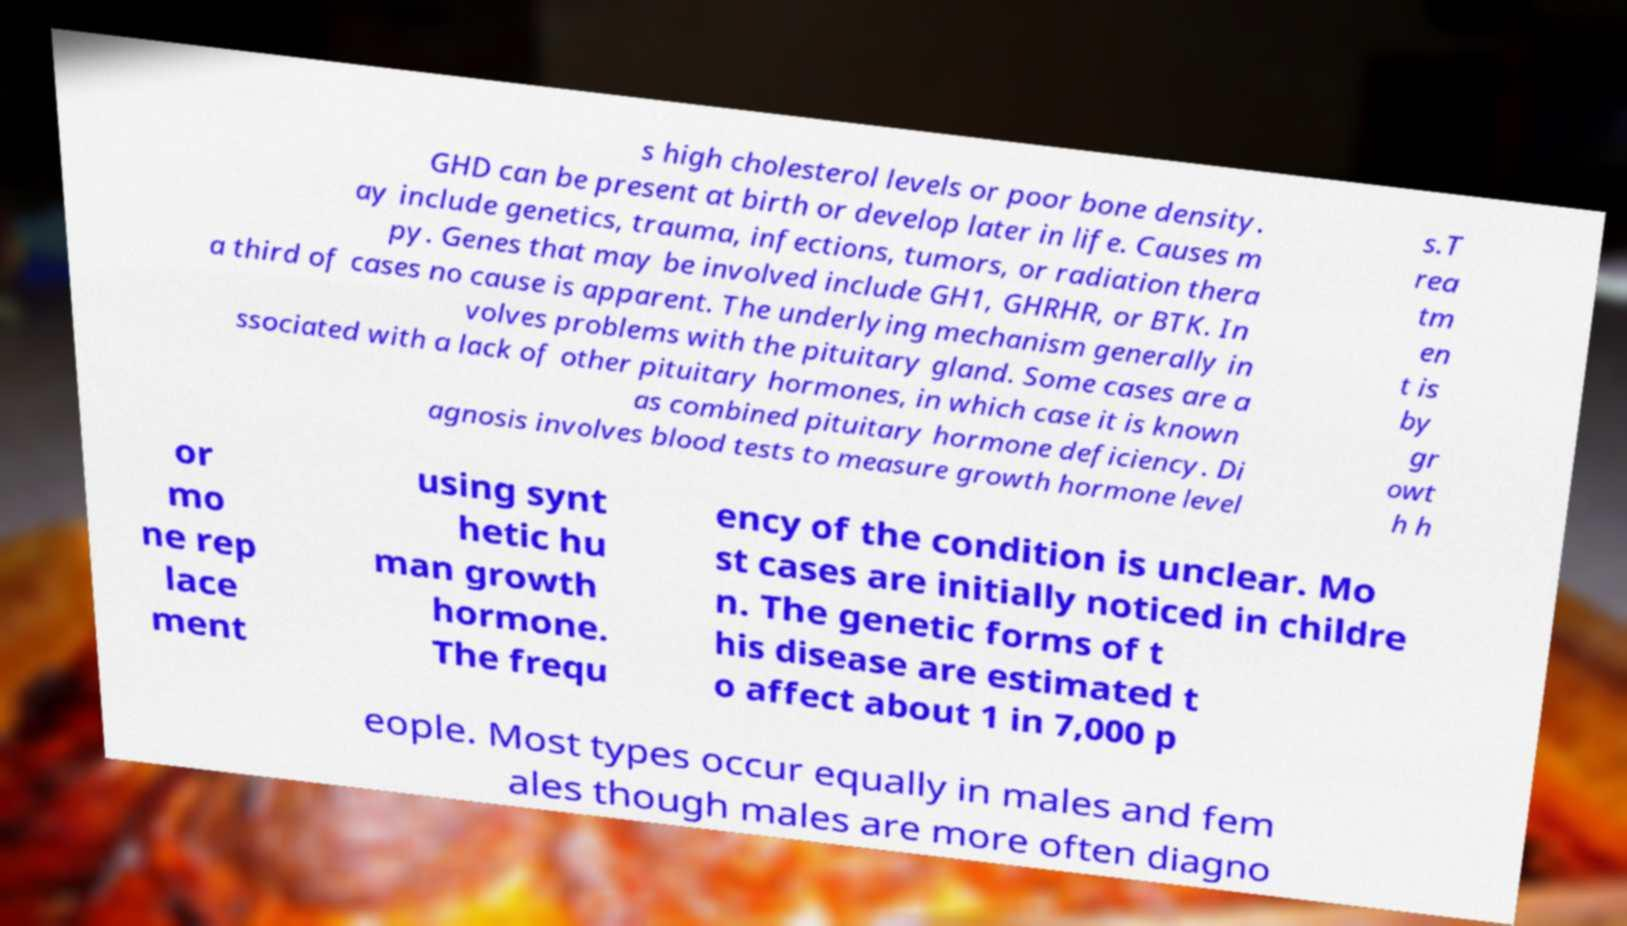Please read and relay the text visible in this image. What does it say? s high cholesterol levels or poor bone density. GHD can be present at birth or develop later in life. Causes m ay include genetics, trauma, infections, tumors, or radiation thera py. Genes that may be involved include GH1, GHRHR, or BTK. In a third of cases no cause is apparent. The underlying mechanism generally in volves problems with the pituitary gland. Some cases are a ssociated with a lack of other pituitary hormones, in which case it is known as combined pituitary hormone deficiency. Di agnosis involves blood tests to measure growth hormone level s.T rea tm en t is by gr owt h h or mo ne rep lace ment using synt hetic hu man growth hormone. The frequ ency of the condition is unclear. Mo st cases are initially noticed in childre n. The genetic forms of t his disease are estimated t o affect about 1 in 7,000 p eople. Most types occur equally in males and fem ales though males are more often diagno 